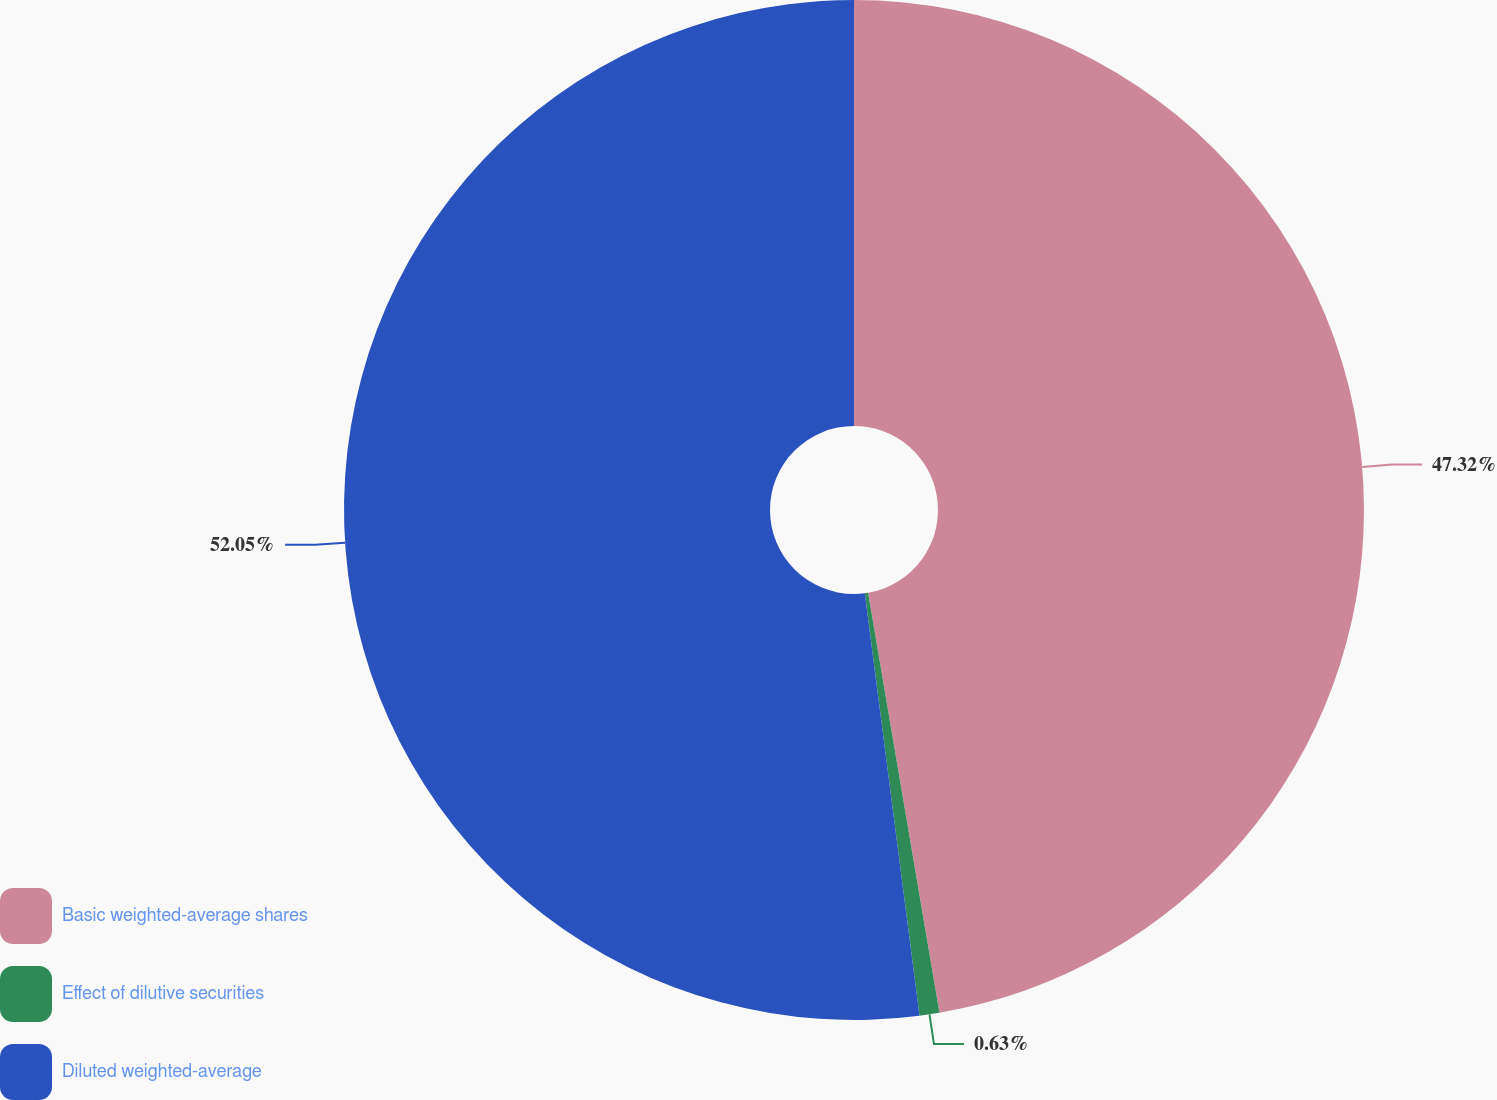<chart> <loc_0><loc_0><loc_500><loc_500><pie_chart><fcel>Basic weighted-average shares<fcel>Effect of dilutive securities<fcel>Diluted weighted-average<nl><fcel>47.32%<fcel>0.63%<fcel>52.05%<nl></chart> 